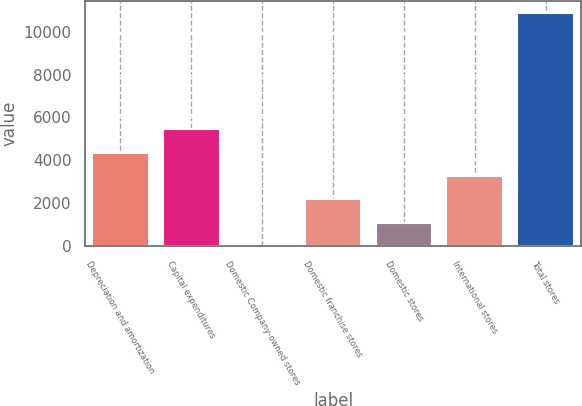<chart> <loc_0><loc_0><loc_500><loc_500><bar_chart><fcel>Depreciation and amortization<fcel>Capital expenditures<fcel>Domestic Company-owned stores<fcel>Domestic franchise stores<fcel>Domestic stores<fcel>International stores<fcel>Total stores<nl><fcel>4356.74<fcel>5444.95<fcel>3.9<fcel>2180.32<fcel>1092.11<fcel>3268.53<fcel>10886<nl></chart> 